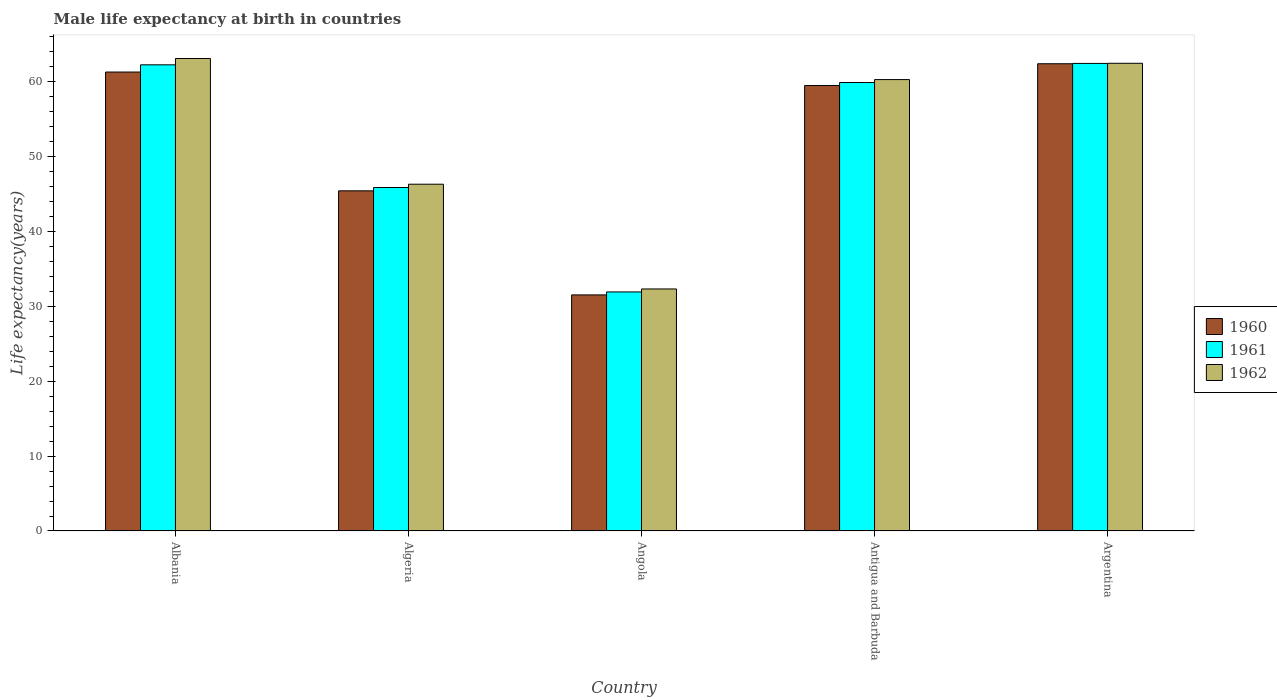How many different coloured bars are there?
Provide a short and direct response. 3. Are the number of bars on each tick of the X-axis equal?
Make the answer very short. Yes. What is the label of the 3rd group of bars from the left?
Keep it short and to the point. Angola. What is the male life expectancy at birth in 1960 in Albania?
Ensure brevity in your answer.  61.31. Across all countries, what is the maximum male life expectancy at birth in 1962?
Offer a very short reply. 63.12. Across all countries, what is the minimum male life expectancy at birth in 1961?
Provide a succinct answer. 31.93. In which country was the male life expectancy at birth in 1960 minimum?
Provide a short and direct response. Angola. What is the total male life expectancy at birth in 1962 in the graph?
Provide a short and direct response. 264.55. What is the difference between the male life expectancy at birth in 1961 in Algeria and that in Angola?
Offer a terse response. 13.95. What is the difference between the male life expectancy at birth in 1962 in Antigua and Barbuda and the male life expectancy at birth in 1960 in Angola?
Provide a succinct answer. 28.76. What is the average male life expectancy at birth in 1962 per country?
Provide a short and direct response. 52.91. What is the difference between the male life expectancy at birth of/in 1962 and male life expectancy at birth of/in 1961 in Antigua and Barbuda?
Offer a terse response. 0.39. In how many countries, is the male life expectancy at birth in 1962 greater than 24 years?
Keep it short and to the point. 5. What is the ratio of the male life expectancy at birth in 1960 in Antigua and Barbuda to that in Argentina?
Make the answer very short. 0.95. What is the difference between the highest and the second highest male life expectancy at birth in 1962?
Provide a succinct answer. -2.18. What is the difference between the highest and the lowest male life expectancy at birth in 1960?
Offer a very short reply. 30.88. Is the sum of the male life expectancy at birth in 1960 in Albania and Argentina greater than the maximum male life expectancy at birth in 1961 across all countries?
Keep it short and to the point. Yes. What does the 2nd bar from the left in Antigua and Barbuda represents?
Your answer should be compact. 1961. How many bars are there?
Keep it short and to the point. 15. Are all the bars in the graph horizontal?
Ensure brevity in your answer.  No. How many countries are there in the graph?
Give a very brief answer. 5. What is the difference between two consecutive major ticks on the Y-axis?
Make the answer very short. 10. Are the values on the major ticks of Y-axis written in scientific E-notation?
Your response must be concise. No. Does the graph contain any zero values?
Provide a succinct answer. No. Does the graph contain grids?
Your response must be concise. No. Where does the legend appear in the graph?
Your answer should be compact. Center right. How many legend labels are there?
Provide a short and direct response. 3. What is the title of the graph?
Your answer should be compact. Male life expectancy at birth in countries. Does "1963" appear as one of the legend labels in the graph?
Your answer should be very brief. No. What is the label or title of the X-axis?
Provide a succinct answer. Country. What is the label or title of the Y-axis?
Your answer should be compact. Life expectancy(years). What is the Life expectancy(years) of 1960 in Albania?
Your response must be concise. 61.31. What is the Life expectancy(years) of 1961 in Albania?
Your answer should be compact. 62.27. What is the Life expectancy(years) in 1962 in Albania?
Offer a very short reply. 63.12. What is the Life expectancy(years) of 1960 in Algeria?
Offer a terse response. 45.44. What is the Life expectancy(years) of 1961 in Algeria?
Provide a short and direct response. 45.88. What is the Life expectancy(years) in 1962 in Algeria?
Keep it short and to the point. 46.33. What is the Life expectancy(years) in 1960 in Angola?
Offer a very short reply. 31.54. What is the Life expectancy(years) in 1961 in Angola?
Your answer should be compact. 31.93. What is the Life expectancy(years) in 1962 in Angola?
Provide a succinct answer. 32.33. What is the Life expectancy(years) of 1960 in Antigua and Barbuda?
Provide a short and direct response. 59.51. What is the Life expectancy(years) of 1961 in Antigua and Barbuda?
Your answer should be compact. 59.91. What is the Life expectancy(years) in 1962 in Antigua and Barbuda?
Keep it short and to the point. 60.3. What is the Life expectancy(years) of 1960 in Argentina?
Make the answer very short. 62.42. What is the Life expectancy(years) of 1961 in Argentina?
Make the answer very short. 62.46. What is the Life expectancy(years) in 1962 in Argentina?
Your response must be concise. 62.48. Across all countries, what is the maximum Life expectancy(years) in 1960?
Your answer should be very brief. 62.42. Across all countries, what is the maximum Life expectancy(years) of 1961?
Offer a very short reply. 62.46. Across all countries, what is the maximum Life expectancy(years) in 1962?
Your answer should be very brief. 63.12. Across all countries, what is the minimum Life expectancy(years) of 1960?
Provide a short and direct response. 31.54. Across all countries, what is the minimum Life expectancy(years) in 1961?
Keep it short and to the point. 31.93. Across all countries, what is the minimum Life expectancy(years) in 1962?
Give a very brief answer. 32.33. What is the total Life expectancy(years) in 1960 in the graph?
Your response must be concise. 260.22. What is the total Life expectancy(years) in 1961 in the graph?
Your answer should be very brief. 262.46. What is the total Life expectancy(years) of 1962 in the graph?
Offer a very short reply. 264.55. What is the difference between the Life expectancy(years) of 1960 in Albania and that in Algeria?
Provide a short and direct response. 15.87. What is the difference between the Life expectancy(years) in 1961 in Albania and that in Algeria?
Provide a succinct answer. 16.39. What is the difference between the Life expectancy(years) of 1962 in Albania and that in Algeria?
Ensure brevity in your answer.  16.79. What is the difference between the Life expectancy(years) of 1960 in Albania and that in Angola?
Keep it short and to the point. 29.77. What is the difference between the Life expectancy(years) in 1961 in Albania and that in Angola?
Ensure brevity in your answer.  30.34. What is the difference between the Life expectancy(years) of 1962 in Albania and that in Angola?
Offer a very short reply. 30.79. What is the difference between the Life expectancy(years) in 1960 in Albania and that in Antigua and Barbuda?
Give a very brief answer. 1.8. What is the difference between the Life expectancy(years) of 1961 in Albania and that in Antigua and Barbuda?
Offer a terse response. 2.36. What is the difference between the Life expectancy(years) in 1962 in Albania and that in Antigua and Barbuda?
Provide a succinct answer. 2.82. What is the difference between the Life expectancy(years) in 1960 in Albania and that in Argentina?
Provide a short and direct response. -1.11. What is the difference between the Life expectancy(years) in 1961 in Albania and that in Argentina?
Your answer should be very brief. -0.19. What is the difference between the Life expectancy(years) of 1962 in Albania and that in Argentina?
Give a very brief answer. 0.64. What is the difference between the Life expectancy(years) of 1960 in Algeria and that in Angola?
Give a very brief answer. 13.9. What is the difference between the Life expectancy(years) of 1961 in Algeria and that in Angola?
Provide a short and direct response. 13.95. What is the difference between the Life expectancy(years) in 1962 in Algeria and that in Angola?
Ensure brevity in your answer.  13.99. What is the difference between the Life expectancy(years) in 1960 in Algeria and that in Antigua and Barbuda?
Your answer should be compact. -14.07. What is the difference between the Life expectancy(years) of 1961 in Algeria and that in Antigua and Barbuda?
Provide a short and direct response. -14.03. What is the difference between the Life expectancy(years) of 1962 in Algeria and that in Antigua and Barbuda?
Ensure brevity in your answer.  -13.97. What is the difference between the Life expectancy(years) of 1960 in Algeria and that in Argentina?
Your answer should be compact. -16.98. What is the difference between the Life expectancy(years) of 1961 in Algeria and that in Argentina?
Give a very brief answer. -16.58. What is the difference between the Life expectancy(years) in 1962 in Algeria and that in Argentina?
Your answer should be compact. -16.15. What is the difference between the Life expectancy(years) of 1960 in Angola and that in Antigua and Barbuda?
Your answer should be compact. -27.97. What is the difference between the Life expectancy(years) in 1961 in Angola and that in Antigua and Barbuda?
Keep it short and to the point. -27.98. What is the difference between the Life expectancy(years) of 1962 in Angola and that in Antigua and Barbuda?
Your answer should be compact. -27.97. What is the difference between the Life expectancy(years) in 1960 in Angola and that in Argentina?
Make the answer very short. -30.88. What is the difference between the Life expectancy(years) in 1961 in Angola and that in Argentina?
Keep it short and to the point. -30.52. What is the difference between the Life expectancy(years) in 1962 in Angola and that in Argentina?
Offer a very short reply. -30.15. What is the difference between the Life expectancy(years) in 1960 in Antigua and Barbuda and that in Argentina?
Offer a terse response. -2.9. What is the difference between the Life expectancy(years) of 1961 in Antigua and Barbuda and that in Argentina?
Give a very brief answer. -2.55. What is the difference between the Life expectancy(years) of 1962 in Antigua and Barbuda and that in Argentina?
Ensure brevity in your answer.  -2.18. What is the difference between the Life expectancy(years) in 1960 in Albania and the Life expectancy(years) in 1961 in Algeria?
Ensure brevity in your answer.  15.43. What is the difference between the Life expectancy(years) of 1960 in Albania and the Life expectancy(years) of 1962 in Algeria?
Give a very brief answer. 14.98. What is the difference between the Life expectancy(years) in 1961 in Albania and the Life expectancy(years) in 1962 in Algeria?
Offer a very short reply. 15.95. What is the difference between the Life expectancy(years) of 1960 in Albania and the Life expectancy(years) of 1961 in Angola?
Your answer should be compact. 29.37. What is the difference between the Life expectancy(years) of 1960 in Albania and the Life expectancy(years) of 1962 in Angola?
Provide a short and direct response. 28.98. What is the difference between the Life expectancy(years) in 1961 in Albania and the Life expectancy(years) in 1962 in Angola?
Provide a short and direct response. 29.94. What is the difference between the Life expectancy(years) of 1960 in Albania and the Life expectancy(years) of 1961 in Antigua and Barbuda?
Keep it short and to the point. 1.4. What is the difference between the Life expectancy(years) of 1961 in Albania and the Life expectancy(years) of 1962 in Antigua and Barbuda?
Give a very brief answer. 1.97. What is the difference between the Life expectancy(years) of 1960 in Albania and the Life expectancy(years) of 1961 in Argentina?
Offer a very short reply. -1.15. What is the difference between the Life expectancy(years) in 1960 in Albania and the Life expectancy(years) in 1962 in Argentina?
Keep it short and to the point. -1.17. What is the difference between the Life expectancy(years) in 1961 in Albania and the Life expectancy(years) in 1962 in Argentina?
Your answer should be very brief. -0.2. What is the difference between the Life expectancy(years) in 1960 in Algeria and the Life expectancy(years) in 1961 in Angola?
Make the answer very short. 13.51. What is the difference between the Life expectancy(years) of 1960 in Algeria and the Life expectancy(years) of 1962 in Angola?
Make the answer very short. 13.11. What is the difference between the Life expectancy(years) in 1961 in Algeria and the Life expectancy(years) in 1962 in Angola?
Ensure brevity in your answer.  13.55. What is the difference between the Life expectancy(years) of 1960 in Algeria and the Life expectancy(years) of 1961 in Antigua and Barbuda?
Your answer should be compact. -14.47. What is the difference between the Life expectancy(years) of 1960 in Algeria and the Life expectancy(years) of 1962 in Antigua and Barbuda?
Make the answer very short. -14.86. What is the difference between the Life expectancy(years) in 1961 in Algeria and the Life expectancy(years) in 1962 in Antigua and Barbuda?
Make the answer very short. -14.42. What is the difference between the Life expectancy(years) in 1960 in Algeria and the Life expectancy(years) in 1961 in Argentina?
Your answer should be compact. -17.02. What is the difference between the Life expectancy(years) of 1960 in Algeria and the Life expectancy(years) of 1962 in Argentina?
Give a very brief answer. -17.04. What is the difference between the Life expectancy(years) in 1961 in Algeria and the Life expectancy(years) in 1962 in Argentina?
Your answer should be compact. -16.59. What is the difference between the Life expectancy(years) in 1960 in Angola and the Life expectancy(years) in 1961 in Antigua and Barbuda?
Offer a very short reply. -28.37. What is the difference between the Life expectancy(years) in 1960 in Angola and the Life expectancy(years) in 1962 in Antigua and Barbuda?
Provide a short and direct response. -28.76. What is the difference between the Life expectancy(years) of 1961 in Angola and the Life expectancy(years) of 1962 in Antigua and Barbuda?
Give a very brief answer. -28.36. What is the difference between the Life expectancy(years) in 1960 in Angola and the Life expectancy(years) in 1961 in Argentina?
Give a very brief answer. -30.92. What is the difference between the Life expectancy(years) in 1960 in Angola and the Life expectancy(years) in 1962 in Argentina?
Offer a terse response. -30.94. What is the difference between the Life expectancy(years) in 1961 in Angola and the Life expectancy(years) in 1962 in Argentina?
Your answer should be compact. -30.54. What is the difference between the Life expectancy(years) in 1960 in Antigua and Barbuda and the Life expectancy(years) in 1961 in Argentina?
Offer a very short reply. -2.95. What is the difference between the Life expectancy(years) in 1960 in Antigua and Barbuda and the Life expectancy(years) in 1962 in Argentina?
Keep it short and to the point. -2.96. What is the difference between the Life expectancy(years) in 1961 in Antigua and Barbuda and the Life expectancy(years) in 1962 in Argentina?
Make the answer very short. -2.56. What is the average Life expectancy(years) in 1960 per country?
Offer a terse response. 52.04. What is the average Life expectancy(years) in 1961 per country?
Your answer should be very brief. 52.49. What is the average Life expectancy(years) in 1962 per country?
Offer a very short reply. 52.91. What is the difference between the Life expectancy(years) of 1960 and Life expectancy(years) of 1961 in Albania?
Offer a very short reply. -0.96. What is the difference between the Life expectancy(years) in 1960 and Life expectancy(years) in 1962 in Albania?
Ensure brevity in your answer.  -1.81. What is the difference between the Life expectancy(years) of 1961 and Life expectancy(years) of 1962 in Albania?
Your answer should be very brief. -0.84. What is the difference between the Life expectancy(years) of 1960 and Life expectancy(years) of 1961 in Algeria?
Offer a very short reply. -0.44. What is the difference between the Life expectancy(years) of 1960 and Life expectancy(years) of 1962 in Algeria?
Your answer should be very brief. -0.89. What is the difference between the Life expectancy(years) in 1961 and Life expectancy(years) in 1962 in Algeria?
Offer a terse response. -0.44. What is the difference between the Life expectancy(years) of 1960 and Life expectancy(years) of 1961 in Angola?
Your response must be concise. -0.4. What is the difference between the Life expectancy(years) in 1960 and Life expectancy(years) in 1962 in Angola?
Keep it short and to the point. -0.79. What is the difference between the Life expectancy(years) of 1961 and Life expectancy(years) of 1962 in Angola?
Give a very brief answer. -0.4. What is the difference between the Life expectancy(years) of 1960 and Life expectancy(years) of 1962 in Antigua and Barbuda?
Provide a short and direct response. -0.79. What is the difference between the Life expectancy(years) of 1961 and Life expectancy(years) of 1962 in Antigua and Barbuda?
Give a very brief answer. -0.39. What is the difference between the Life expectancy(years) in 1960 and Life expectancy(years) in 1961 in Argentina?
Offer a terse response. -0.04. What is the difference between the Life expectancy(years) of 1960 and Life expectancy(years) of 1962 in Argentina?
Make the answer very short. -0.06. What is the difference between the Life expectancy(years) in 1961 and Life expectancy(years) in 1962 in Argentina?
Your answer should be compact. -0.02. What is the ratio of the Life expectancy(years) in 1960 in Albania to that in Algeria?
Offer a terse response. 1.35. What is the ratio of the Life expectancy(years) of 1961 in Albania to that in Algeria?
Make the answer very short. 1.36. What is the ratio of the Life expectancy(years) of 1962 in Albania to that in Algeria?
Your answer should be very brief. 1.36. What is the ratio of the Life expectancy(years) of 1960 in Albania to that in Angola?
Ensure brevity in your answer.  1.94. What is the ratio of the Life expectancy(years) in 1961 in Albania to that in Angola?
Provide a succinct answer. 1.95. What is the ratio of the Life expectancy(years) of 1962 in Albania to that in Angola?
Provide a succinct answer. 1.95. What is the ratio of the Life expectancy(years) of 1960 in Albania to that in Antigua and Barbuda?
Offer a terse response. 1.03. What is the ratio of the Life expectancy(years) of 1961 in Albania to that in Antigua and Barbuda?
Your answer should be very brief. 1.04. What is the ratio of the Life expectancy(years) of 1962 in Albania to that in Antigua and Barbuda?
Make the answer very short. 1.05. What is the ratio of the Life expectancy(years) of 1960 in Albania to that in Argentina?
Your answer should be very brief. 0.98. What is the ratio of the Life expectancy(years) of 1961 in Albania to that in Argentina?
Your answer should be compact. 1. What is the ratio of the Life expectancy(years) in 1962 in Albania to that in Argentina?
Make the answer very short. 1.01. What is the ratio of the Life expectancy(years) of 1960 in Algeria to that in Angola?
Your answer should be very brief. 1.44. What is the ratio of the Life expectancy(years) of 1961 in Algeria to that in Angola?
Provide a short and direct response. 1.44. What is the ratio of the Life expectancy(years) of 1962 in Algeria to that in Angola?
Offer a terse response. 1.43. What is the ratio of the Life expectancy(years) in 1960 in Algeria to that in Antigua and Barbuda?
Provide a succinct answer. 0.76. What is the ratio of the Life expectancy(years) in 1961 in Algeria to that in Antigua and Barbuda?
Your answer should be very brief. 0.77. What is the ratio of the Life expectancy(years) of 1962 in Algeria to that in Antigua and Barbuda?
Keep it short and to the point. 0.77. What is the ratio of the Life expectancy(years) of 1960 in Algeria to that in Argentina?
Provide a short and direct response. 0.73. What is the ratio of the Life expectancy(years) of 1961 in Algeria to that in Argentina?
Give a very brief answer. 0.73. What is the ratio of the Life expectancy(years) in 1962 in Algeria to that in Argentina?
Your response must be concise. 0.74. What is the ratio of the Life expectancy(years) of 1960 in Angola to that in Antigua and Barbuda?
Provide a succinct answer. 0.53. What is the ratio of the Life expectancy(years) in 1961 in Angola to that in Antigua and Barbuda?
Your answer should be compact. 0.53. What is the ratio of the Life expectancy(years) in 1962 in Angola to that in Antigua and Barbuda?
Give a very brief answer. 0.54. What is the ratio of the Life expectancy(years) in 1960 in Angola to that in Argentina?
Your answer should be compact. 0.51. What is the ratio of the Life expectancy(years) in 1961 in Angola to that in Argentina?
Give a very brief answer. 0.51. What is the ratio of the Life expectancy(years) of 1962 in Angola to that in Argentina?
Keep it short and to the point. 0.52. What is the ratio of the Life expectancy(years) in 1960 in Antigua and Barbuda to that in Argentina?
Provide a succinct answer. 0.95. What is the ratio of the Life expectancy(years) in 1961 in Antigua and Barbuda to that in Argentina?
Keep it short and to the point. 0.96. What is the ratio of the Life expectancy(years) of 1962 in Antigua and Barbuda to that in Argentina?
Give a very brief answer. 0.97. What is the difference between the highest and the second highest Life expectancy(years) of 1960?
Give a very brief answer. 1.11. What is the difference between the highest and the second highest Life expectancy(years) of 1961?
Provide a short and direct response. 0.19. What is the difference between the highest and the second highest Life expectancy(years) of 1962?
Your answer should be very brief. 0.64. What is the difference between the highest and the lowest Life expectancy(years) in 1960?
Provide a short and direct response. 30.88. What is the difference between the highest and the lowest Life expectancy(years) in 1961?
Provide a short and direct response. 30.52. What is the difference between the highest and the lowest Life expectancy(years) of 1962?
Make the answer very short. 30.79. 